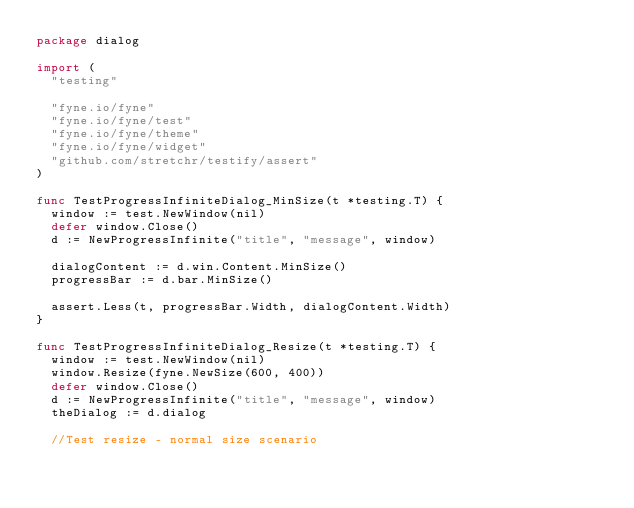Convert code to text. <code><loc_0><loc_0><loc_500><loc_500><_Go_>package dialog

import (
	"testing"

	"fyne.io/fyne"
	"fyne.io/fyne/test"
	"fyne.io/fyne/theme"
	"fyne.io/fyne/widget"
	"github.com/stretchr/testify/assert"
)

func TestProgressInfiniteDialog_MinSize(t *testing.T) {
	window := test.NewWindow(nil)
	defer window.Close()
	d := NewProgressInfinite("title", "message", window)

	dialogContent := d.win.Content.MinSize()
	progressBar := d.bar.MinSize()

	assert.Less(t, progressBar.Width, dialogContent.Width)
}

func TestProgressInfiniteDialog_Resize(t *testing.T) {
	window := test.NewWindow(nil)
	window.Resize(fyne.NewSize(600, 400))
	defer window.Close()
	d := NewProgressInfinite("title", "message", window)
	theDialog := d.dialog

	//Test resize - normal size scenario</code> 